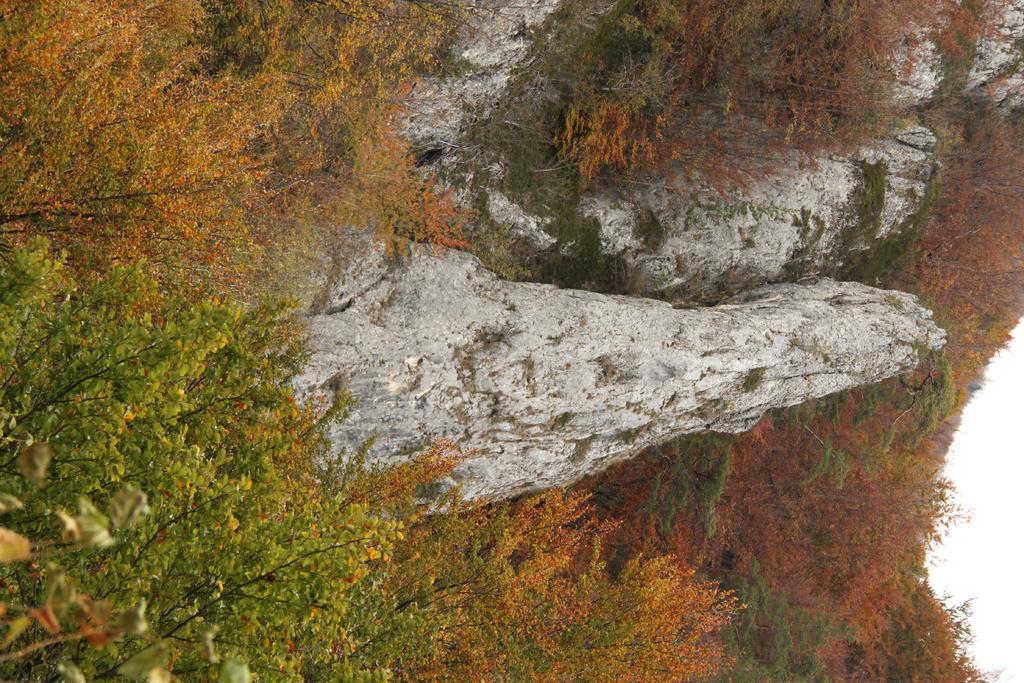Describe this image in one or two sentences. In this picture we can see plants, trees and mountains. 